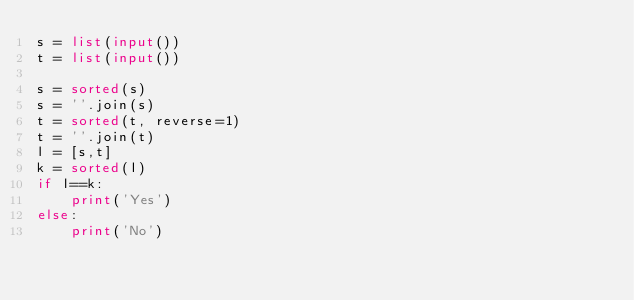<code> <loc_0><loc_0><loc_500><loc_500><_Python_>s = list(input())
t = list(input())

s = sorted(s)
s = ''.join(s)
t = sorted(t, reverse=1)
t = ''.join(t)
l = [s,t]
k = sorted(l)
if l==k:
    print('Yes')
else:
    print('No')</code> 